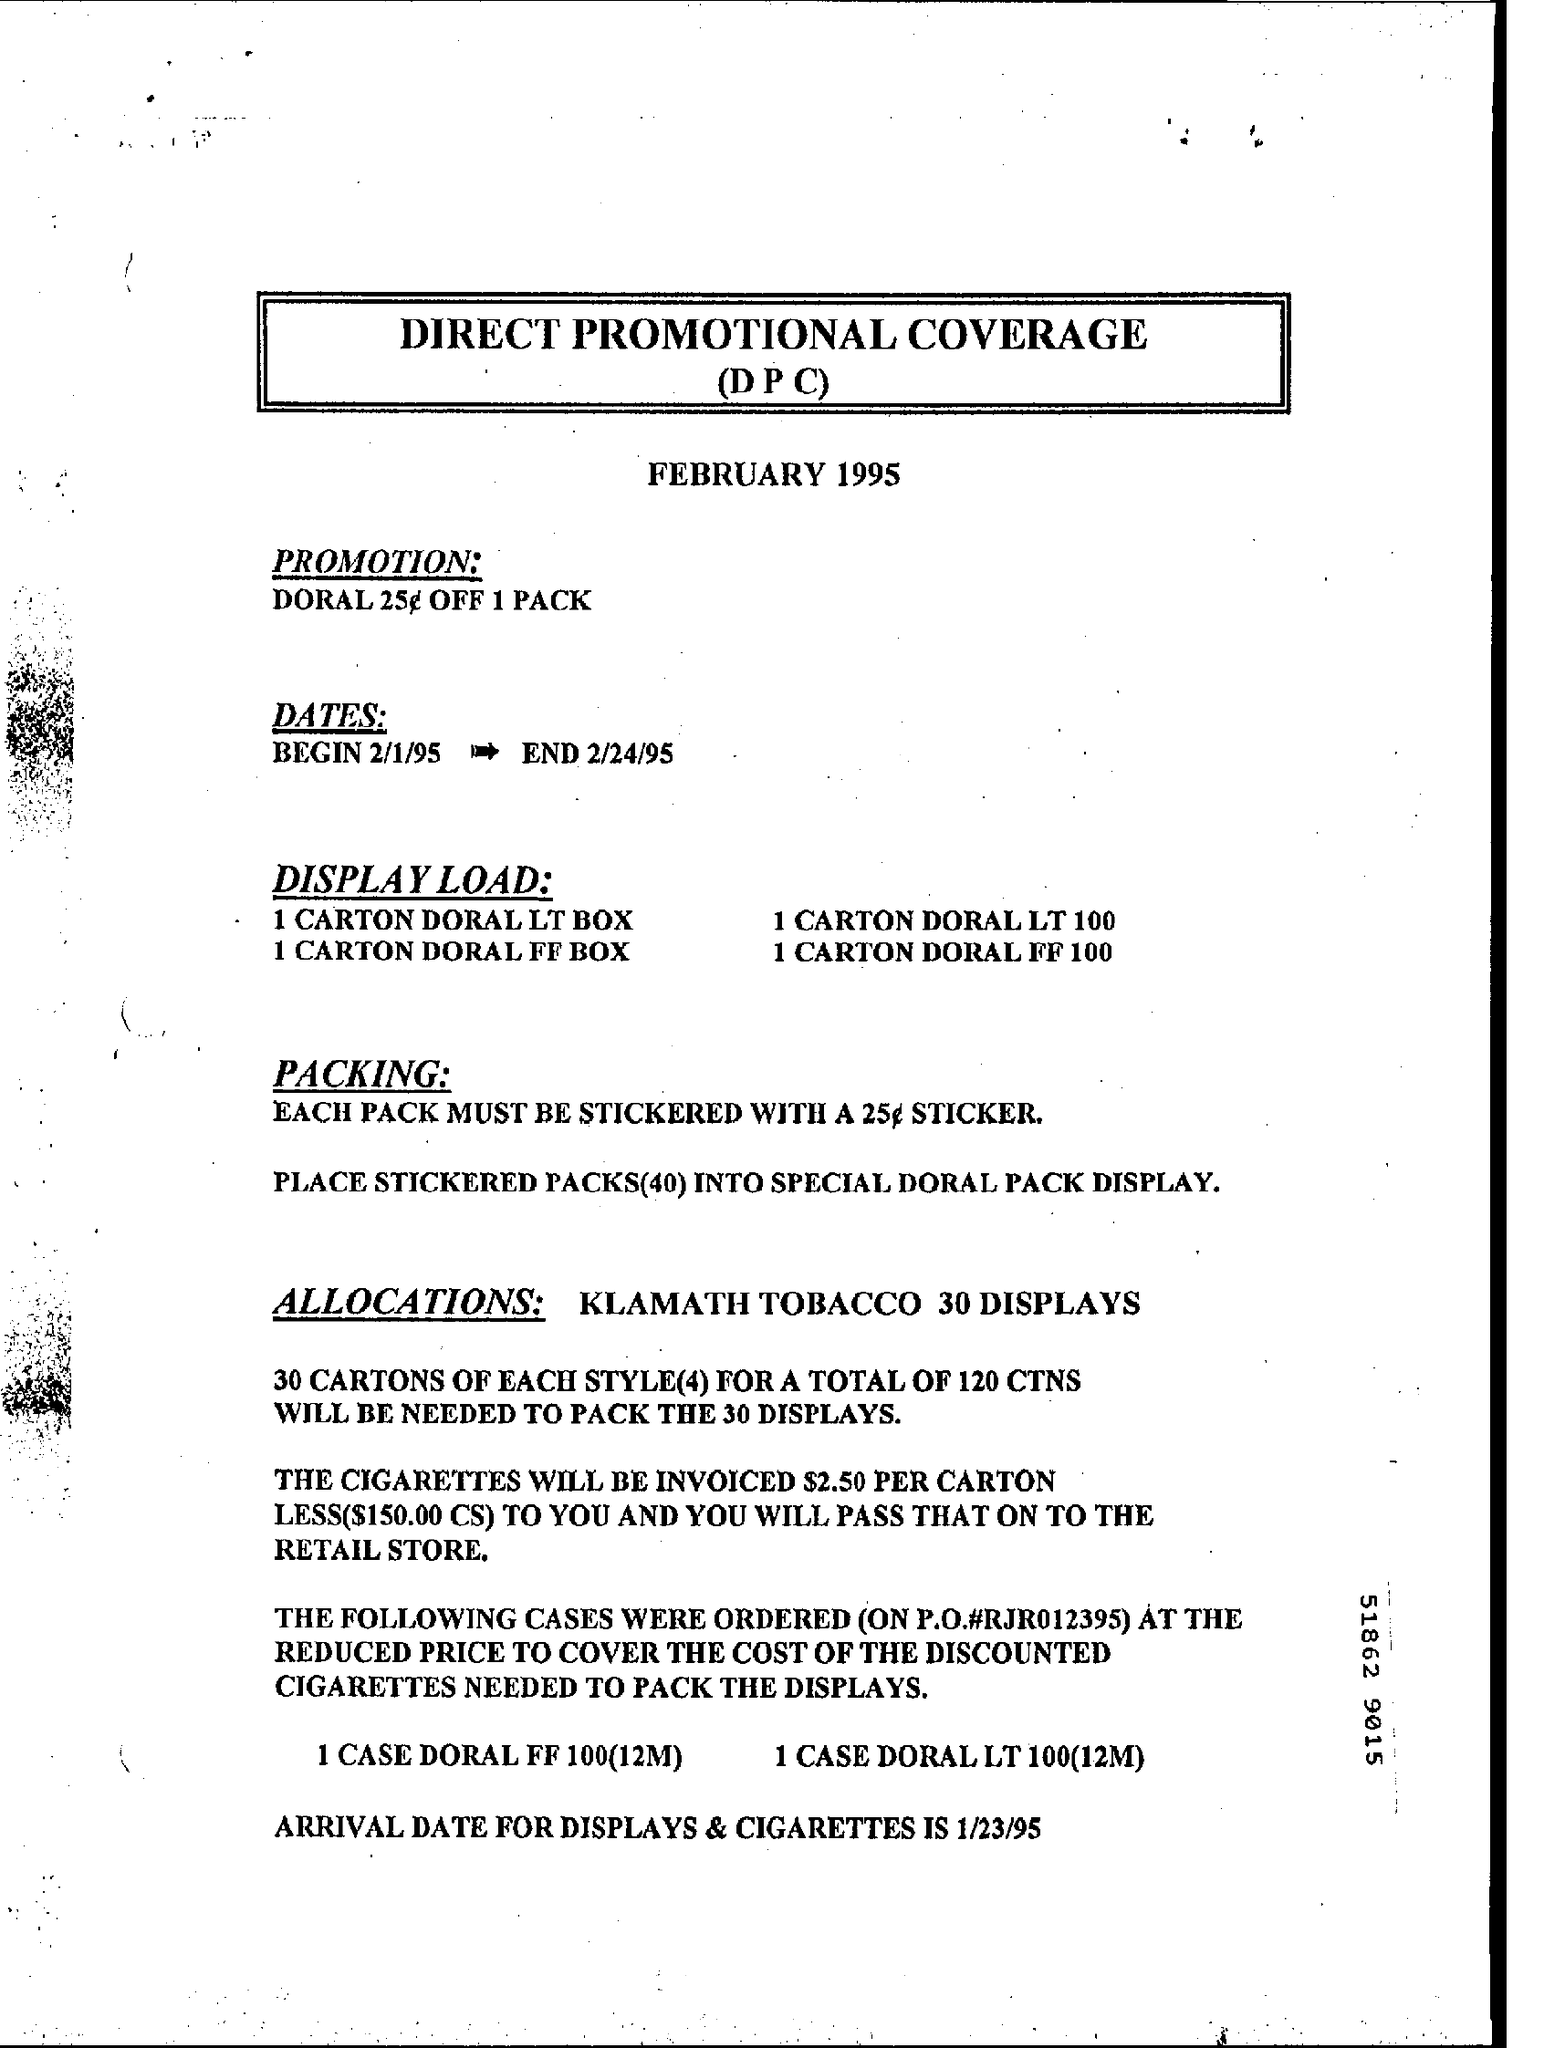What is the Fullform for DPC ?
Keep it short and to the point. DIRECT PROMOTIONAL COVERAGE. What is the Beginning Date ?
Make the answer very short. 2/1/95. What is the Ending Date ?
Give a very brief answer. 2/24/95. 